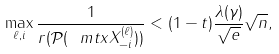Convert formula to latex. <formula><loc_0><loc_0><loc_500><loc_500>\max _ { \ell , i } \frac { 1 } { r ( \mathcal { P } ( \ m t x { X } ^ { ( \ell ) } _ { - i } ) ) } < ( 1 - t ) \frac { \lambda ( \gamma ) } { \sqrt { e } } \sqrt { n } ,</formula> 